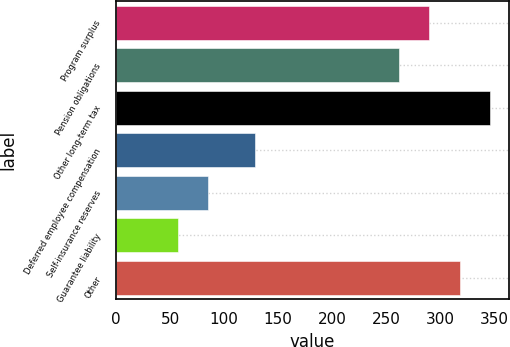Convert chart. <chart><loc_0><loc_0><loc_500><loc_500><bar_chart><fcel>Program surplus<fcel>Pension obligations<fcel>Other long-term tax<fcel>Deferred employee compensation<fcel>Self-insurance reserves<fcel>Guarantee liability<fcel>Other<nl><fcel>290.3<fcel>262<fcel>346.9<fcel>129<fcel>85.3<fcel>57<fcel>318.6<nl></chart> 